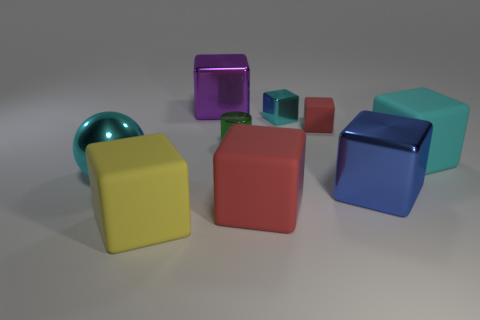Are any large cyan metal objects visible? Yes, there is a large cyan-colored metal box visible among the objects shown in the image. 